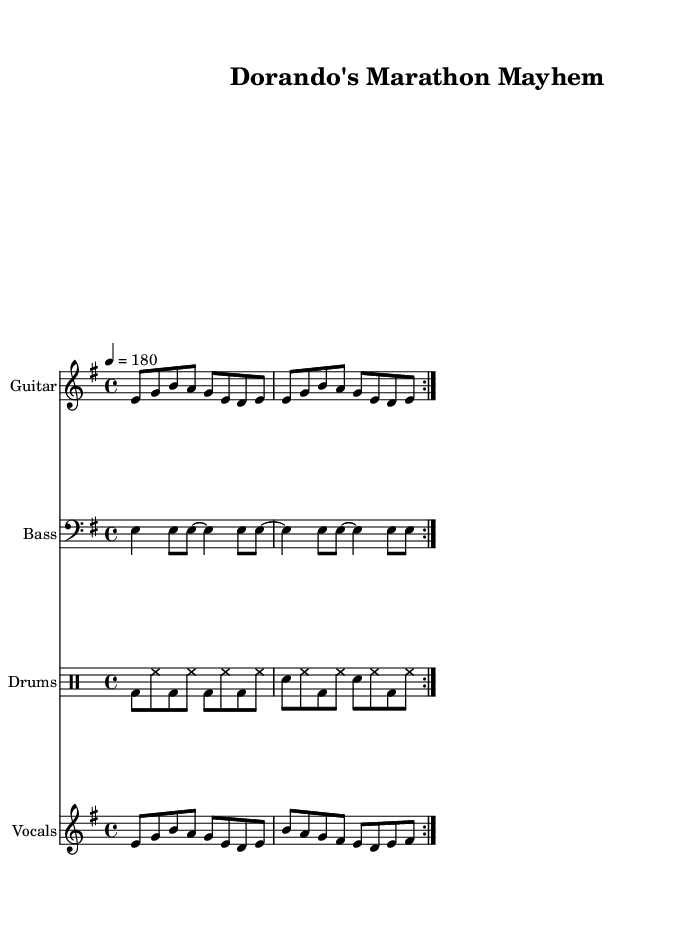What is the key signature of this music? The key signature is E minor, which is indicated by one sharp (F#). In the global section of the code, it specifies \key e \minor, confirming the use of E minor throughout the piece.
Answer: E minor What is the time signature of this music? The time signature is indicated by \time 4/4 in the global section of the code, which means the piece is structured in four beats per measure.
Answer: 4/4 What is the tempo marking for this piece? The tempo marking is shown as 4 = 180 in the global section, which signifies that there are 180 beats per minute, creating a fast-paced rhythm appropriate for punk music.
Answer: 180 How many repeated sections are there in the vocal part? The vocal part has two repetitions, indicated by the \repeat volta 2 section in the code. This suggests that the vocals, along with the accompanying music, are to be played two times in succession.
Answer: 2 What is the primary theme of the lyrics? The lyrics revolve around Dorando Pietri, an Italian marathon runner who is celebrated in this tribute. The words reflect his pride and the chaos of his performance in the 1908 London Olympics.
Answer: Dorando Pietri What kind of instruments are included in the score? The score includes Electric Guitar, Bass, Drums, and Vocals. Each instrument is designated in the score section, allowing for a full punk rock band setup.
Answer: Electric Guitar, Bass, Drums, Vocals What genre does this piece represent? This piece represents punk rock, characterized by its fast tempo, aggressive sound, and themes celebrating athleticism and historical figures. The overall style is consistent with the punk genre and its typical tribute format.
Answer: Punk rock 